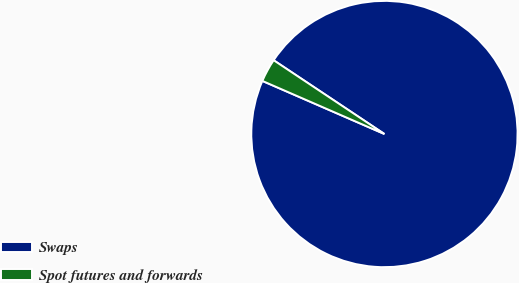Convert chart. <chart><loc_0><loc_0><loc_500><loc_500><pie_chart><fcel>Swaps<fcel>Spot futures and forwards<nl><fcel>97.18%<fcel>2.82%<nl></chart> 